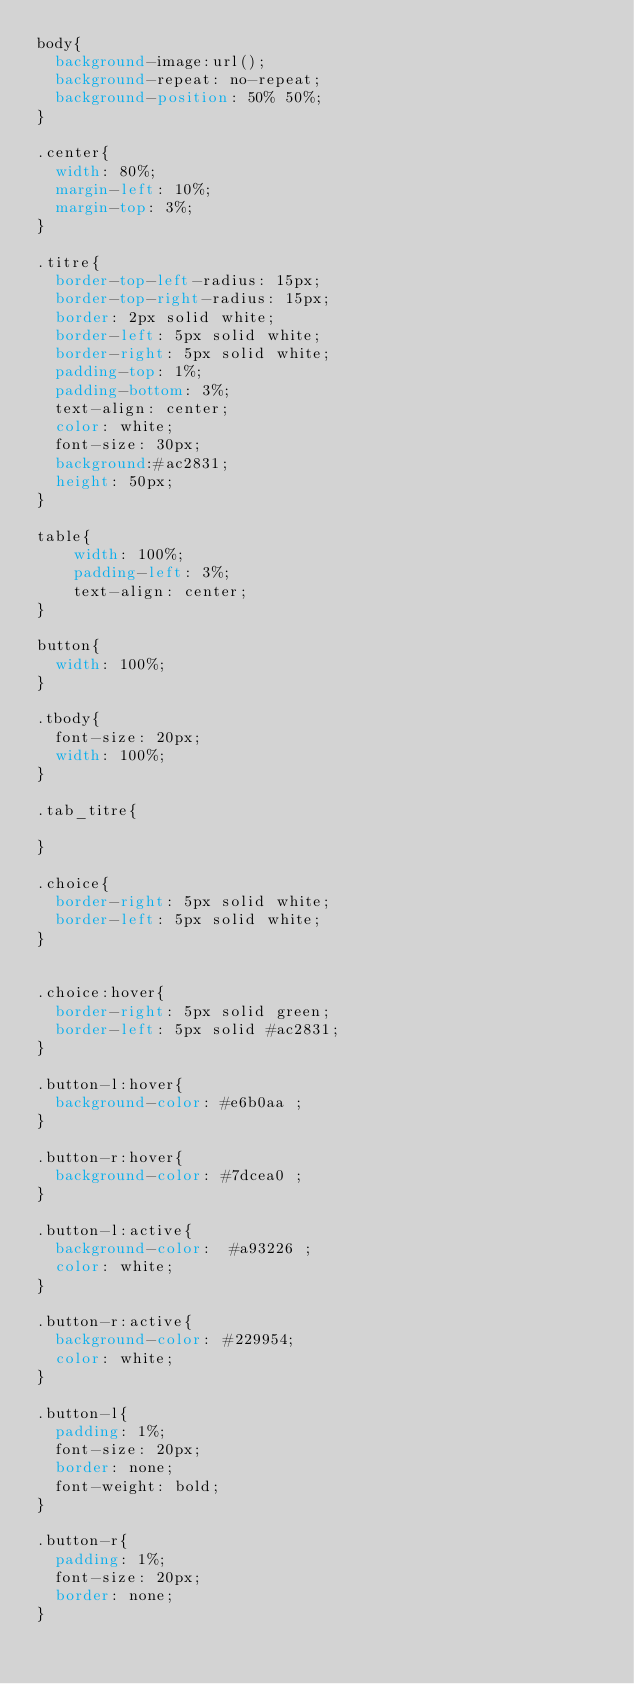Convert code to text. <code><loc_0><loc_0><loc_500><loc_500><_CSS_>body{
  background-image:url();
  background-repeat: no-repeat;
  background-position: 50% 50%;
}

.center{
  width: 80%;
  margin-left: 10%;
  margin-top: 3%;
}

.titre{
  border-top-left-radius: 15px;
  border-top-right-radius: 15px;
  border: 2px solid white;
  border-left: 5px solid white;
  border-right: 5px solid white;
  padding-top: 1%;
  padding-bottom: 3%;
  text-align: center;
  color: white;
  font-size: 30px;
  background:#ac2831;
  height: 50px;
}

table{
    width: 100%;
    padding-left: 3%;
    text-align: center;
}

button{
  width: 100%;
}

.tbody{
  font-size: 20px;
  width: 100%;
}

.tab_titre{

}

.choice{
  border-right: 5px solid white;
  border-left: 5px solid white;
}


.choice:hover{
  border-right: 5px solid green;
  border-left: 5px solid #ac2831;
}

.button-l:hover{
  background-color: #e6b0aa ;
}

.button-r:hover{
  background-color: #7dcea0 ;
}

.button-l:active{
  background-color:  #a93226 ;
  color: white;
}

.button-r:active{
  background-color: #229954;
  color: white;
}

.button-l{
  padding: 1%;
  font-size: 20px;
  border: none;
  font-weight: bold;
}

.button-r{
  padding: 1%;
  font-size: 20px;
  border: none;
}
</code> 